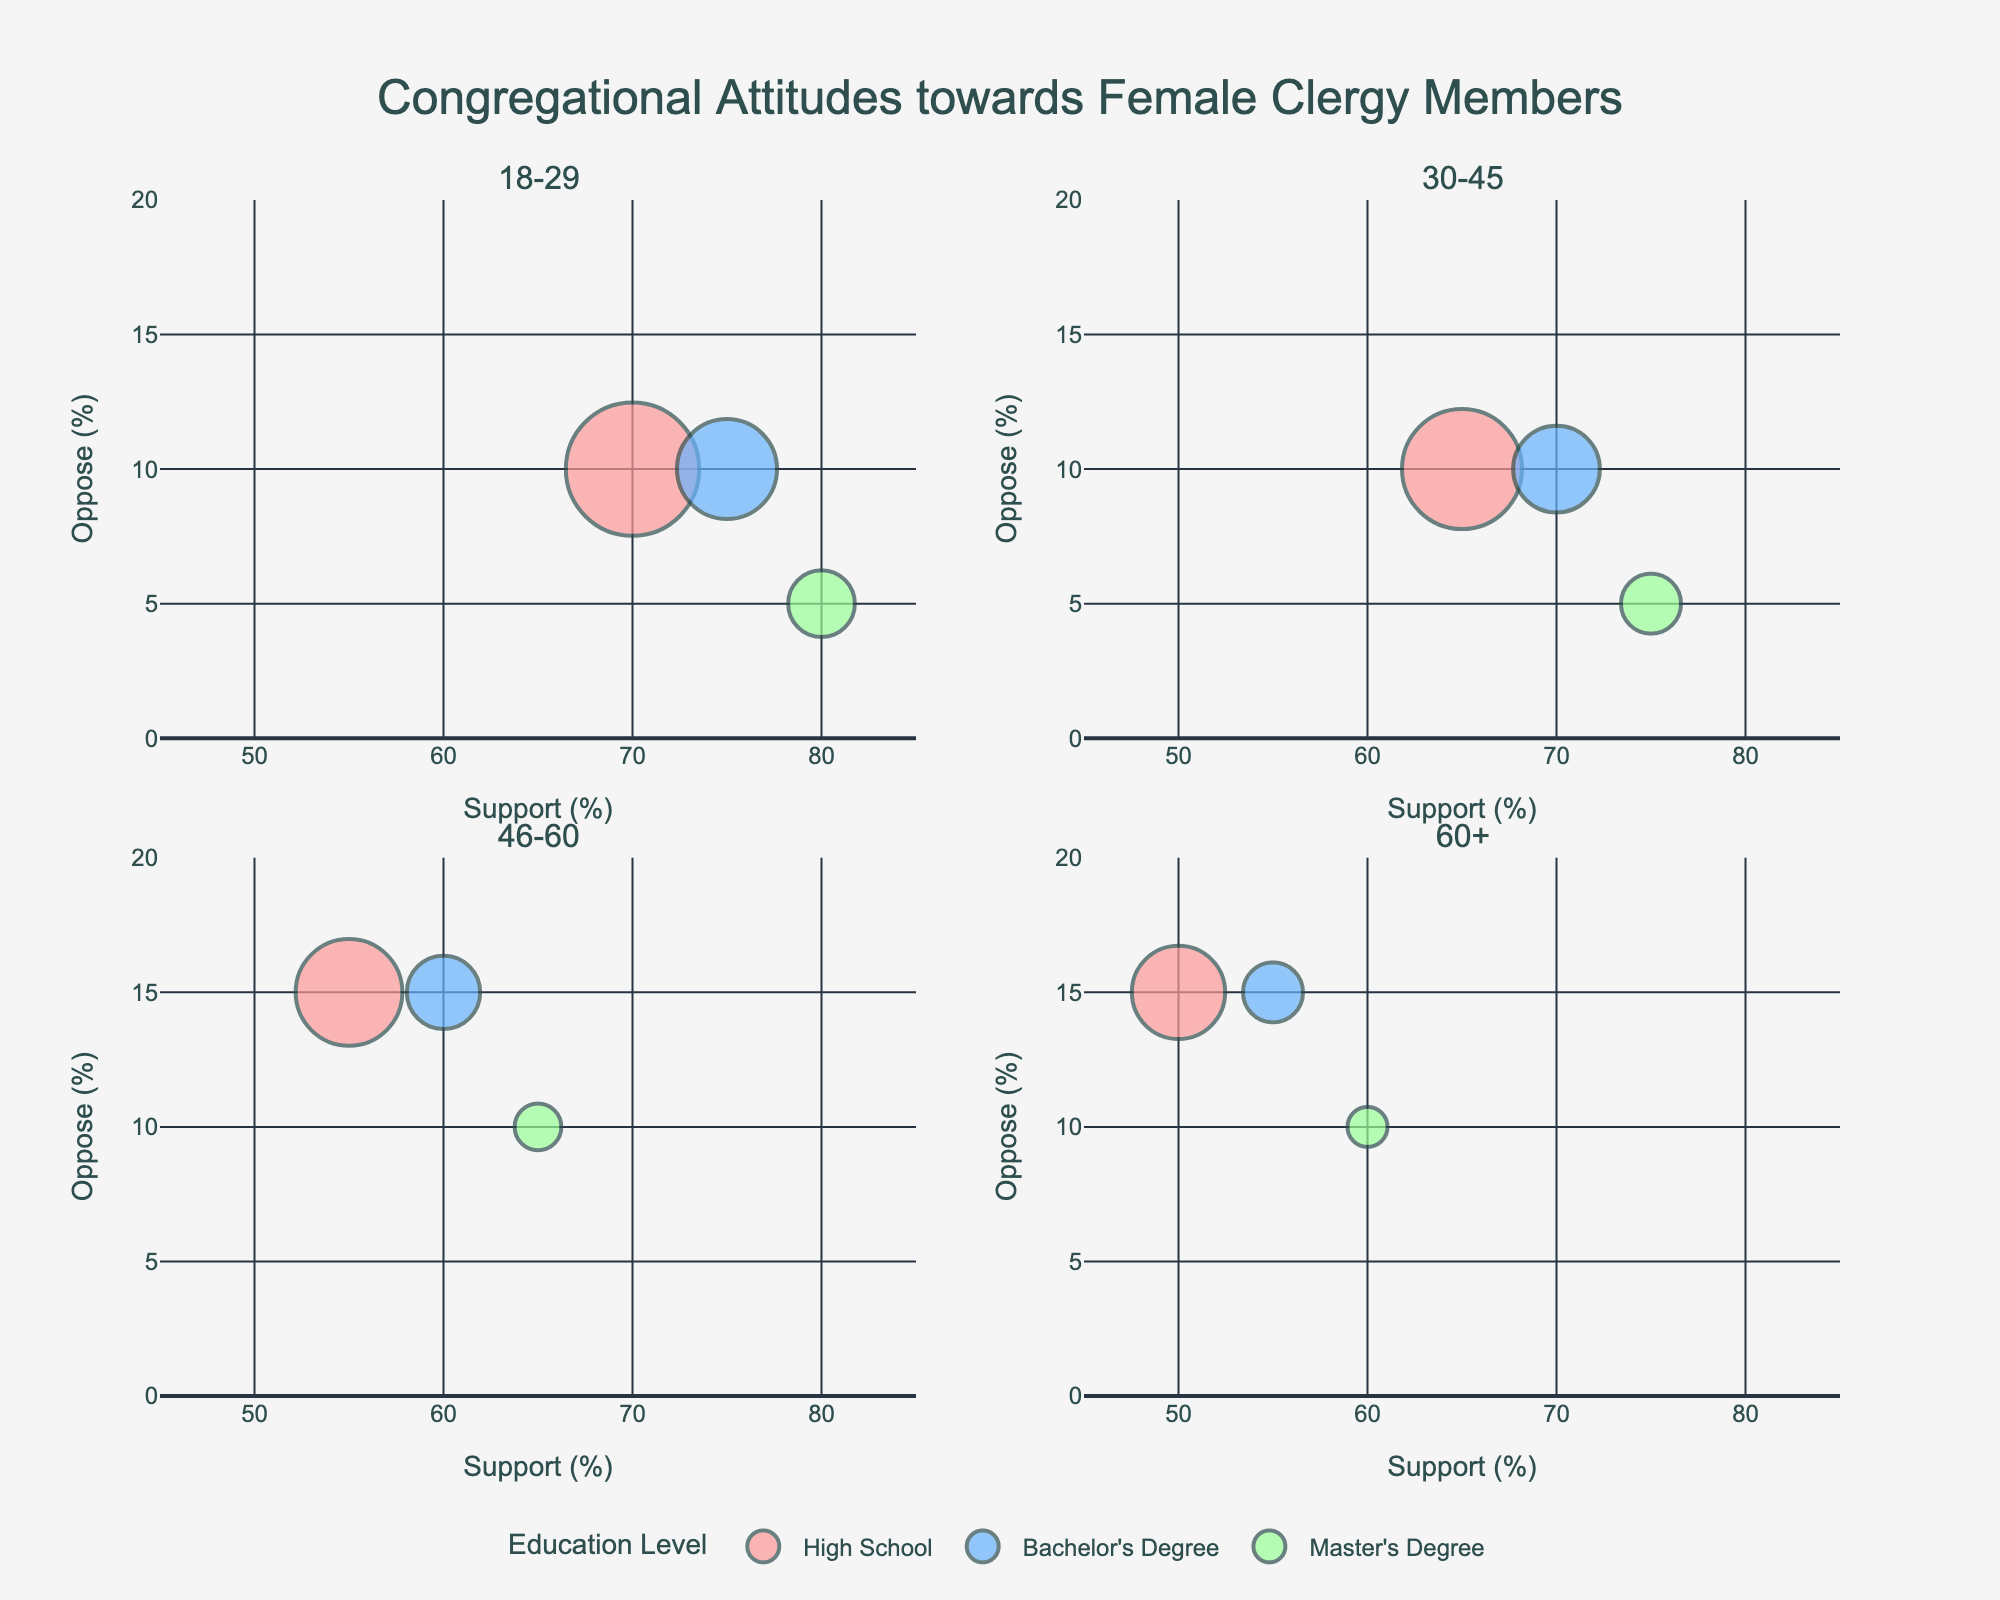What age group has the most support for female clergy members with a Master's Degree? In the 18-29 age group, the support for female clergy members with a Master's Degree is at 80%, which is higher than all other age groups for this education level.
Answer: 18-29 How does the percentage of opposition to female clergy members compare between high school educated individuals aged 46-60 and those aged 60+? The opposition for high school educated individuals aged 46-60 is 15%, which is the same as those aged 60+, both also at 15%.
Answer: Equal Which age group shows the least support for female clergy members with a Bachelor's Degree? The 60+ age group shows the least support for female clergy members with a Bachelor's Degree at 55%.
Answer: 60+ What is the range of support percentages for female clergy in the 30-45 age group across all education levels? In the 30-45 age group, the support ranges from 65% (High School) to 75% (Master's Degree).
Answer: 65%-75% What age group shows the greatest difference in support for female clergy members between high school and those with a Master's Degree? The 18-29 age group shows the greatest difference in support between those with a High School education (70%) and Master's Degree (80%), a 10% difference.
Answer: 18-29 Is there a correlation between age groups and average attendance at congregations? The average attendance tends to be higher in younger age groups and declines in older age groups. For instance, the 18-29 age group shows higher attendance (200 for High School) compared to the 60+ group (140 for High School).
Answer: Yes, higher attendance in younger groups Which education level shows the least opposition towards female clergy across all age groups? Across all age groups, individuals with a Master's Degree show the least opposition towards female clergy, with the highest opposition percentage not exceeding 10%.
Answer: Master's Degree In the 30-45 age group, how does the support percentage for female clergy members compare between individuals with a Master's Degree and those with a High School education? In the 30-45 age group, support for female clergy members is higher among those with a Master's Degree (75%) compared to those with a High School education (65%).
Answer: Master's Degree support is higher How does the neutral percentage differ between high school educated individuals and those with a Bachelor's Degree in the 60+ age group? In the 60+ age group, the neutral percentage is 35% for high school educated individuals and 30% for those with a Bachelor's Degree, showing a 5% higher neutrality among high school educated individuals.
Answer: 5% What is the attendance trend for Master's Degree holders across different age groups? The average attendance decreases with increasing age for Master's Degree holders: it is highest in the 18-29 group (100) and lowest in the 60+ group (60).
Answer: Decreases with age 